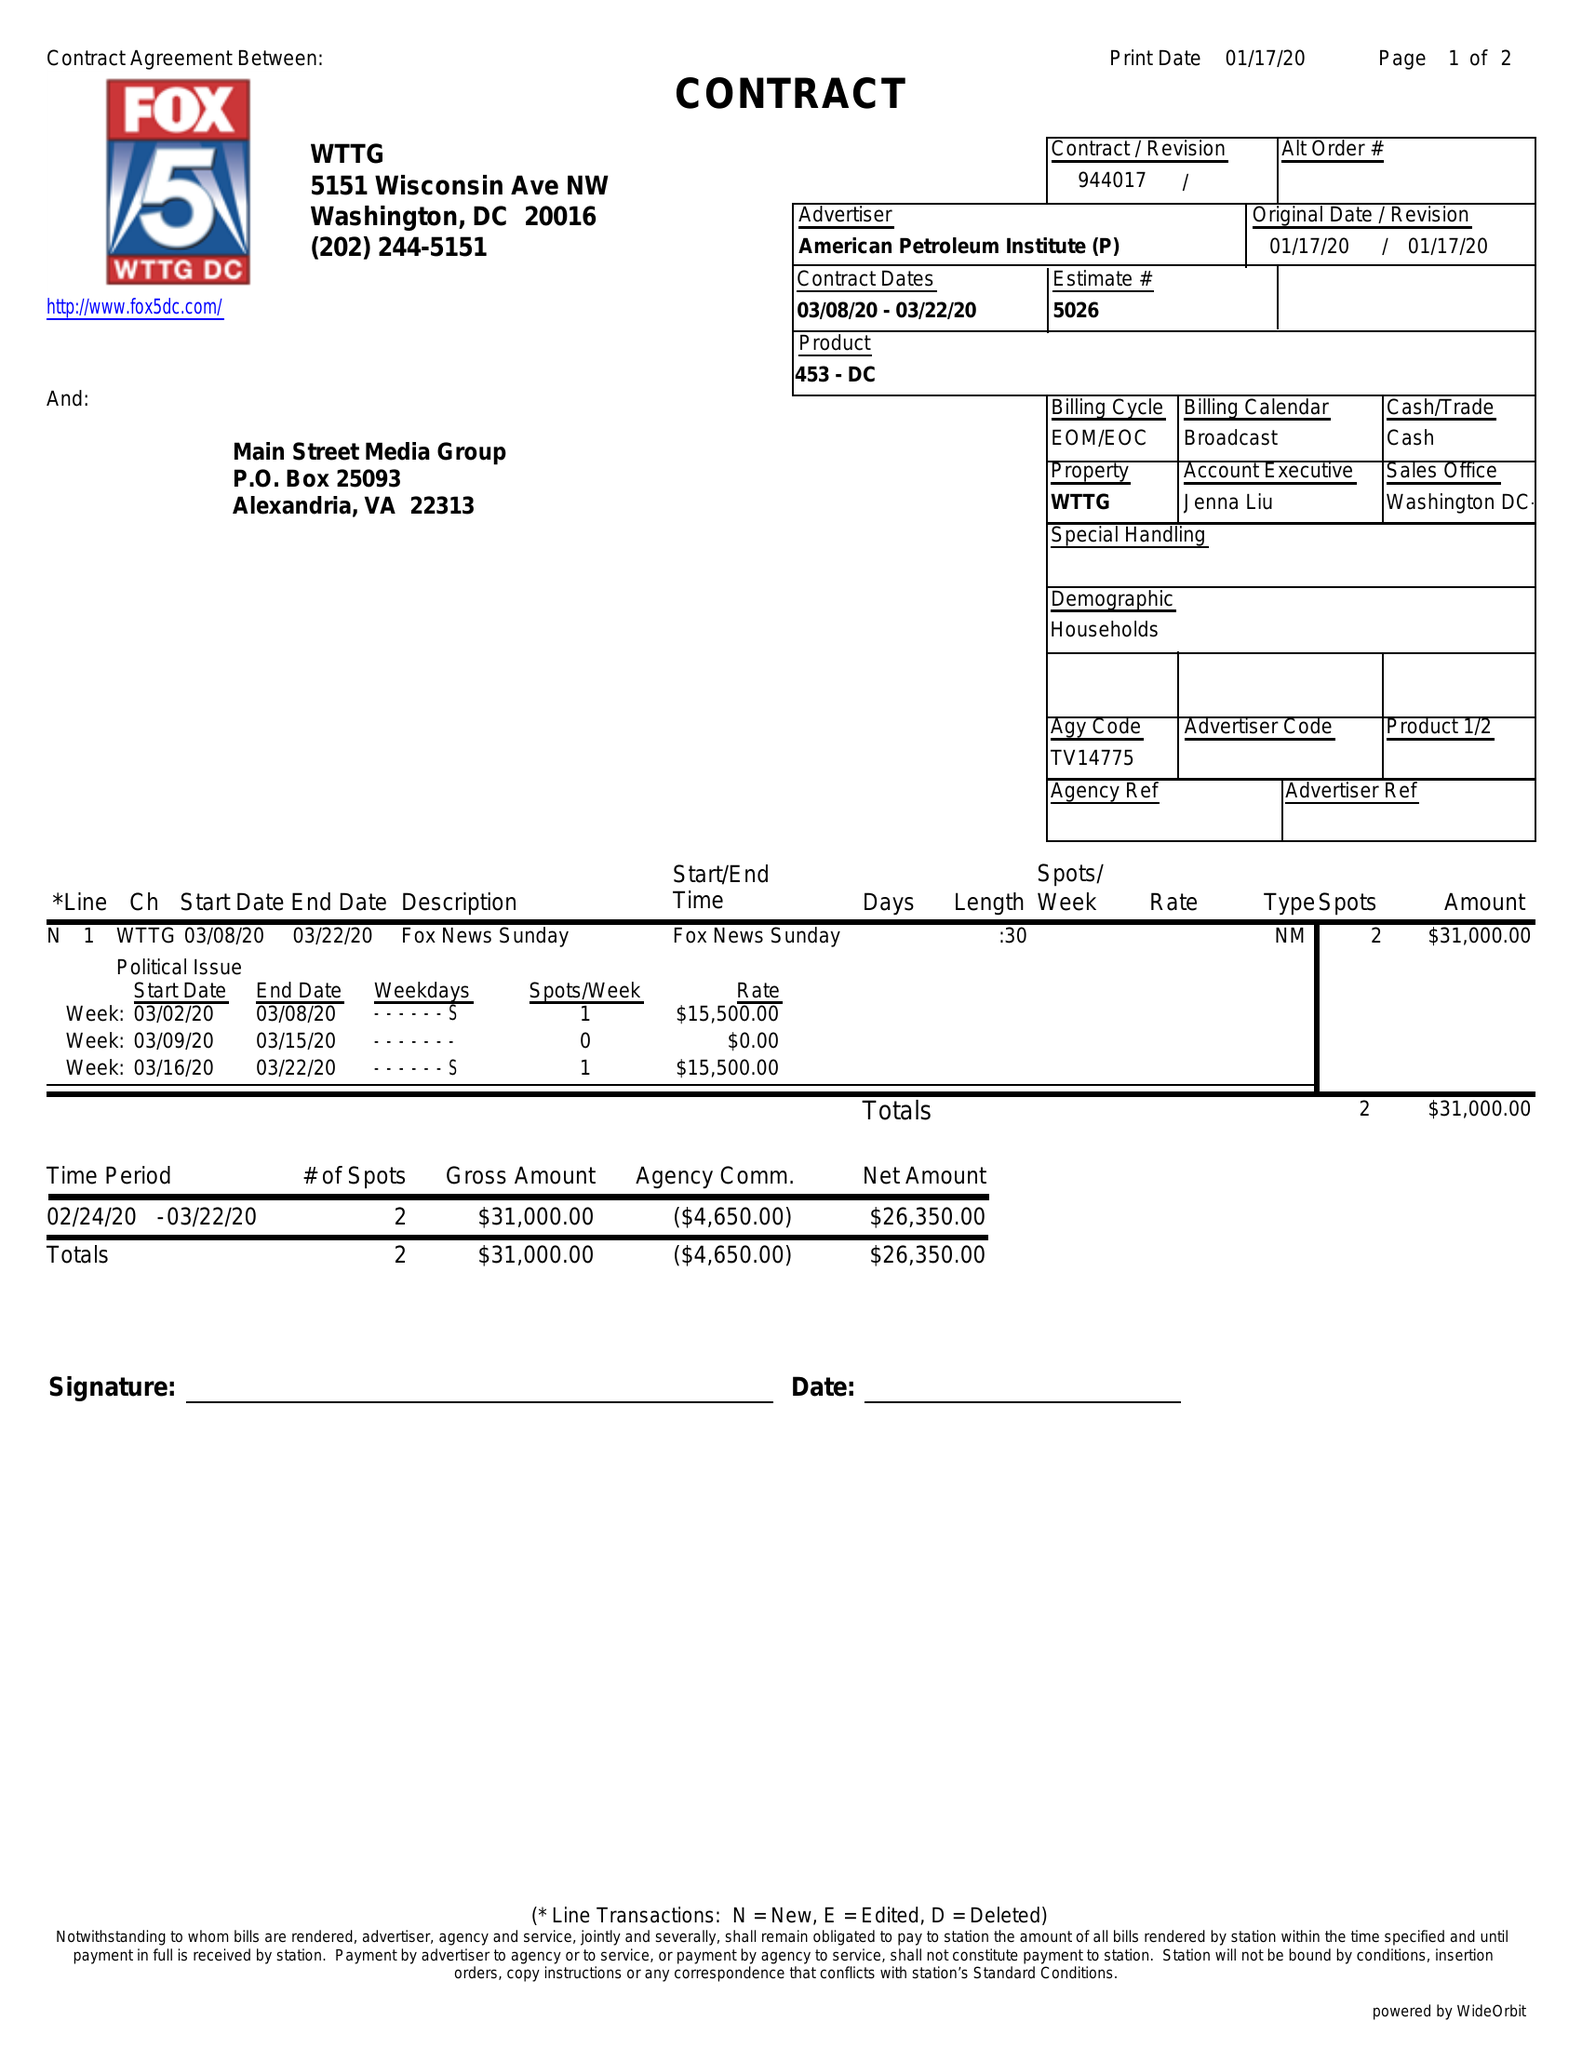What is the value for the contract_num?
Answer the question using a single word or phrase. 944017 